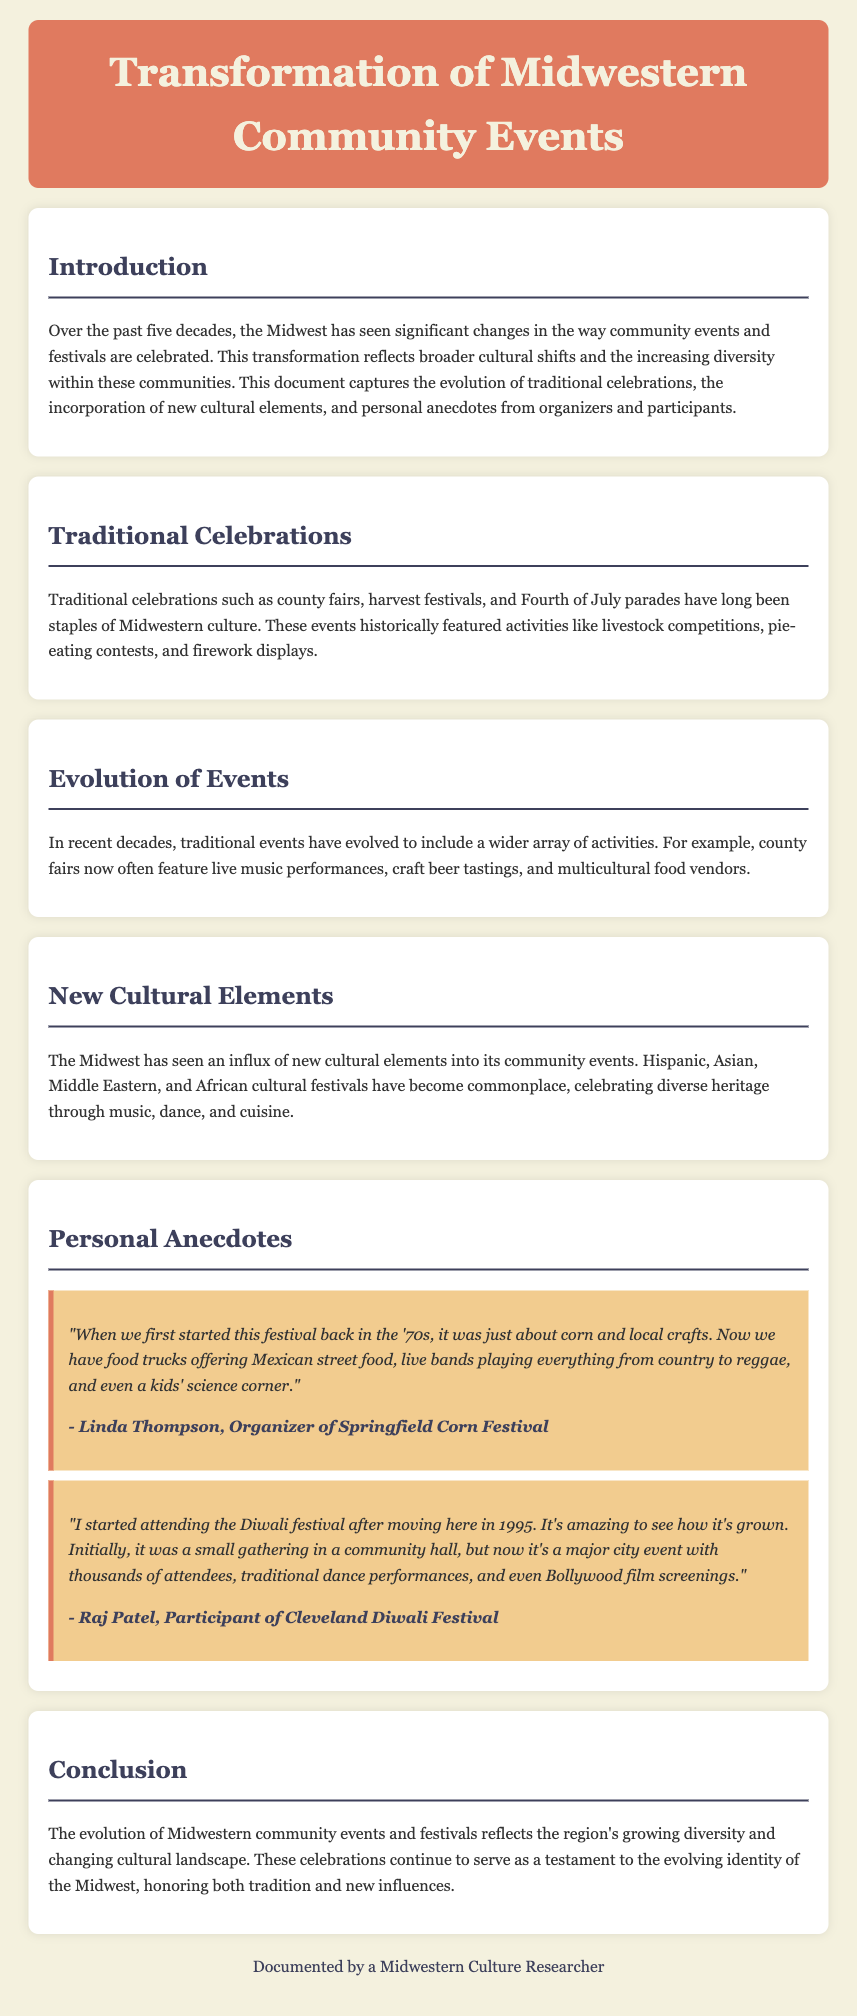What are some traditional celebrations in the Midwest? The document mentions county fairs, harvest festivals, and Fourth of July parades as traditional celebrations.
Answer: county fairs, harvest festivals, Fourth of July parades Who is the organizer of the Springfield Corn Festival? Linda Thompson is identified as the organizer of the Springfield Corn Festival in her anecdote.
Answer: Linda Thompson What type of food vendors are now featured at county fairs? The document states that county fairs now often include multicultural food vendors.
Answer: multicultural food vendors In what year did Raj Patel start attending the Diwali festival? Raj Patel mentions he started attending the Diwali festival after moving to Cleveland in 1995.
Answer: 1995 What has significantly changed about the Diwali festival according to Raj Patel? Raj Patel notes that the Diwali festival has grown from a small gathering in a community hall to a major city event.
Answer: major city event What elements have been incorporated into Midwestern community events over the past five decades? The document highlights the incorporation of new cultural elements such as Hispanic, Asian, Middle Eastern, and African festivals.
Answer: new cultural elements How do community events reflect the Midwestern identity? The document states that these celebrations serve as a testament to the evolving identity of the Midwest.
Answer: testament to the evolving identity What are some activities traditionally featured at Midwest festivals? Historically, events included livestock competitions, pie-eating contests, and firework displays.
Answer: livestock competitions, pie-eating contests, firework displays 